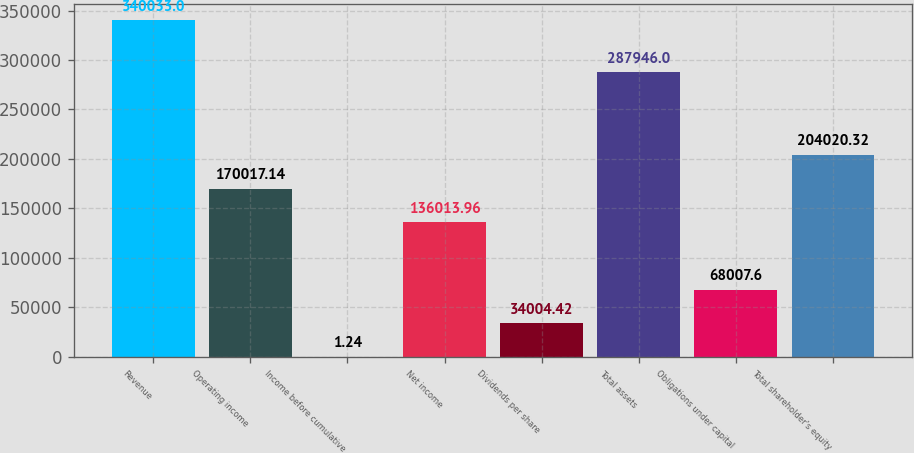Convert chart. <chart><loc_0><loc_0><loc_500><loc_500><bar_chart><fcel>Revenue<fcel>Operating income<fcel>Income before cumulative<fcel>Net income<fcel>Dividends per share<fcel>Total assets<fcel>Obligations under capital<fcel>Total shareholder's equity<nl><fcel>340033<fcel>170017<fcel>1.24<fcel>136014<fcel>34004.4<fcel>287946<fcel>68007.6<fcel>204020<nl></chart> 